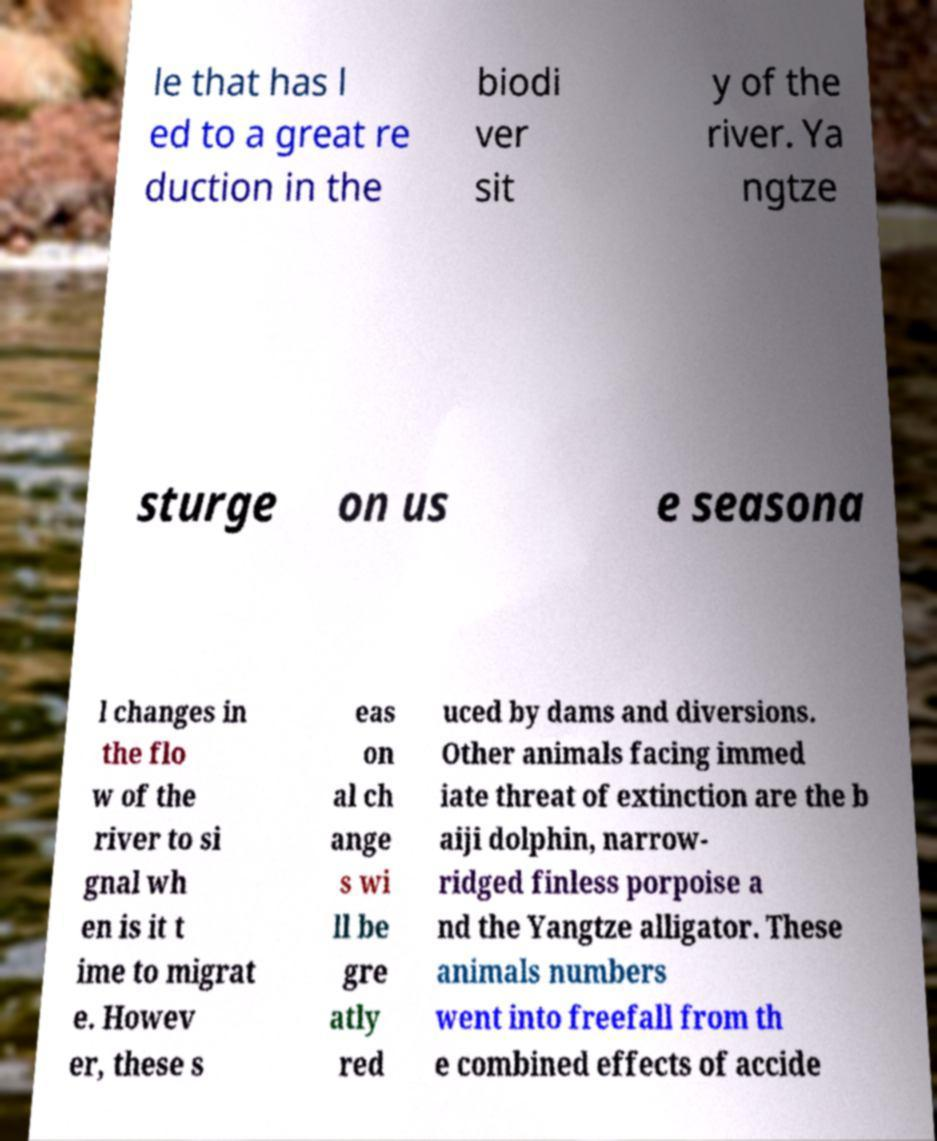Please identify and transcribe the text found in this image. le that has l ed to a great re duction in the biodi ver sit y of the river. Ya ngtze sturge on us e seasona l changes in the flo w of the river to si gnal wh en is it t ime to migrat e. Howev er, these s eas on al ch ange s wi ll be gre atly red uced by dams and diversions. Other animals facing immed iate threat of extinction are the b aiji dolphin, narrow- ridged finless porpoise a nd the Yangtze alligator. These animals numbers went into freefall from th e combined effects of accide 